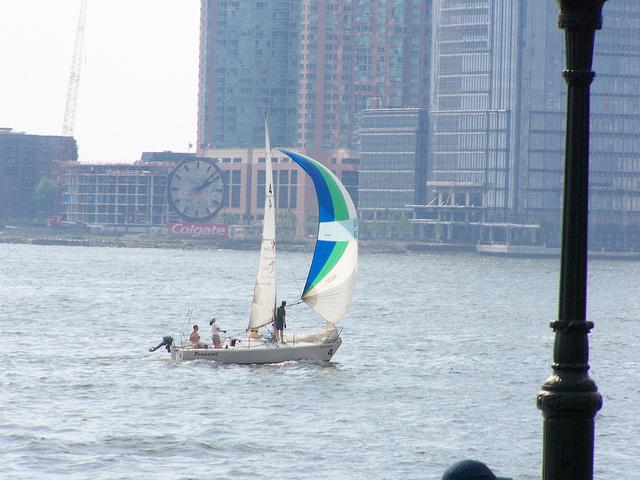What period of the day is shown here? Please explain your reasoning. afternoon. It is sunny. the clock indicates that it is around 2. 